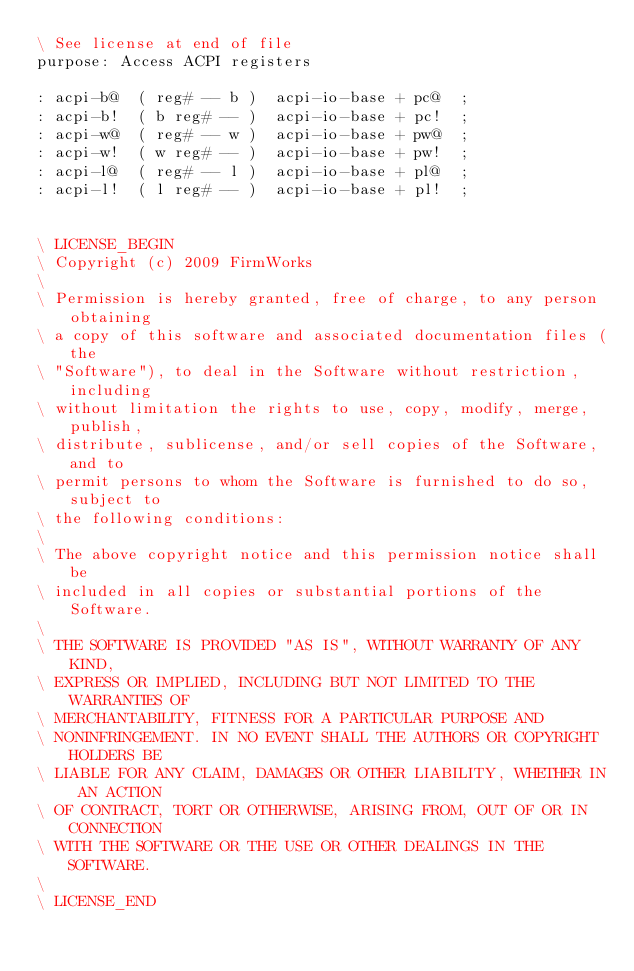<code> <loc_0><loc_0><loc_500><loc_500><_Forth_>\ See license at end of file
purpose: Access ACPI registers

: acpi-b@  ( reg# -- b )  acpi-io-base + pc@  ;
: acpi-b!  ( b reg# -- )  acpi-io-base + pc!  ;
: acpi-w@  ( reg# -- w )  acpi-io-base + pw@  ;
: acpi-w!  ( w reg# -- )  acpi-io-base + pw!  ;
: acpi-l@  ( reg# -- l )  acpi-io-base + pl@  ;
: acpi-l!  ( l reg# -- )  acpi-io-base + pl!  ;


\ LICENSE_BEGIN
\ Copyright (c) 2009 FirmWorks
\ 
\ Permission is hereby granted, free of charge, to any person obtaining
\ a copy of this software and associated documentation files (the
\ "Software"), to deal in the Software without restriction, including
\ without limitation the rights to use, copy, modify, merge, publish,
\ distribute, sublicense, and/or sell copies of the Software, and to
\ permit persons to whom the Software is furnished to do so, subject to
\ the following conditions:
\ 
\ The above copyright notice and this permission notice shall be
\ included in all copies or substantial portions of the Software.
\ 
\ THE SOFTWARE IS PROVIDED "AS IS", WITHOUT WARRANTY OF ANY KIND,
\ EXPRESS OR IMPLIED, INCLUDING BUT NOT LIMITED TO THE WARRANTIES OF
\ MERCHANTABILITY, FITNESS FOR A PARTICULAR PURPOSE AND
\ NONINFRINGEMENT. IN NO EVENT SHALL THE AUTHORS OR COPYRIGHT HOLDERS BE
\ LIABLE FOR ANY CLAIM, DAMAGES OR OTHER LIABILITY, WHETHER IN AN ACTION
\ OF CONTRACT, TORT OR OTHERWISE, ARISING FROM, OUT OF OR IN CONNECTION
\ WITH THE SOFTWARE OR THE USE OR OTHER DEALINGS IN THE SOFTWARE.
\
\ LICENSE_END
</code> 